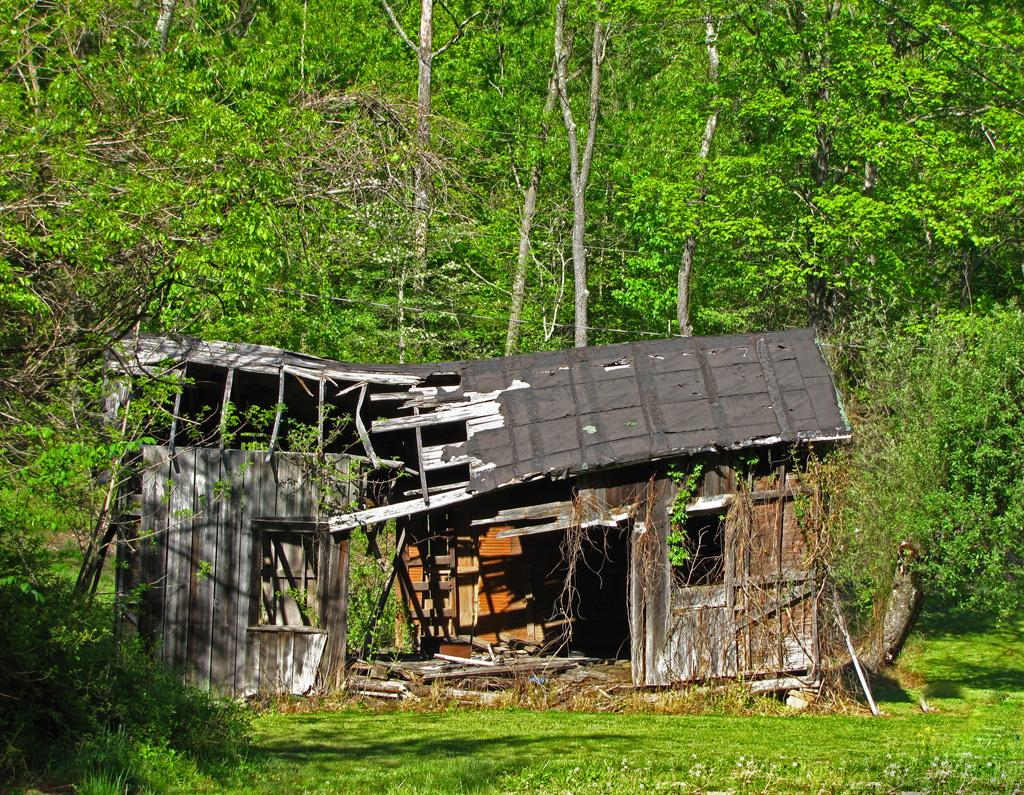What is the main subject in the center of the image? There is a broken house in the center of the image. What can be seen in the background of the image? There are trees in the background of the image. What type of vegetation is at the bottom of the image? There is grass at the bottom of the image. What type of eggs can be seen in the image? There are no eggs present in the image. What action is the broken house taking in the image? The broken house is not an active subject and cannot take any action; it is an inanimate object. 